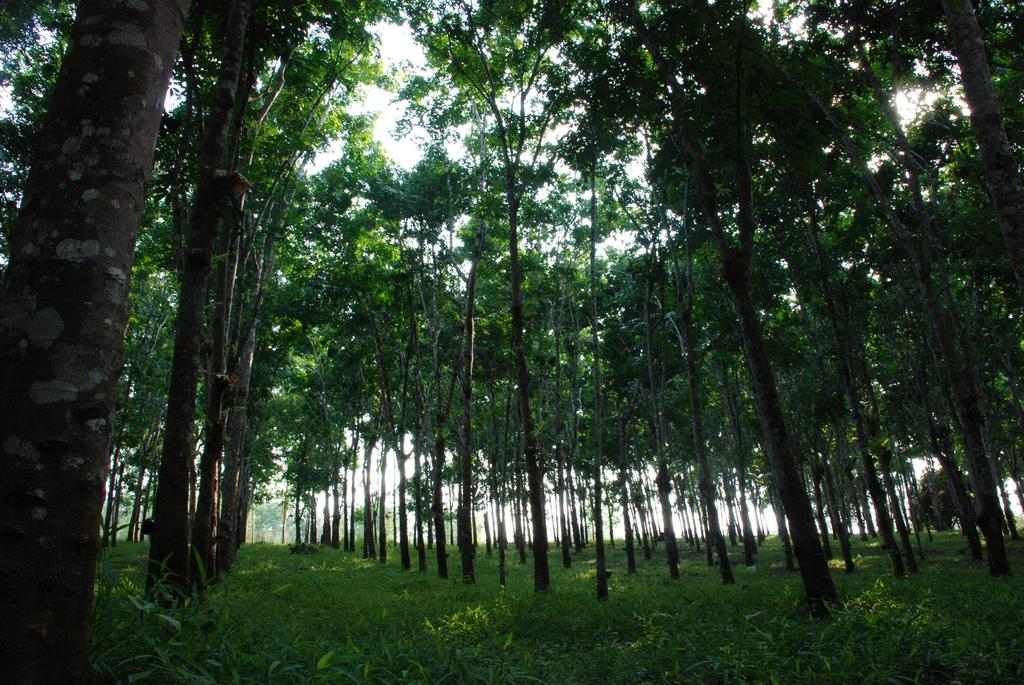What type of vegetation is predominant in the image? There are many tall trees in the image. What is the ground surface like around the trees? The trees are around a grass surface. What type of fuel is being used by the goat in the image? There is no goat present in the image, so it is not possible to determine what type of fuel it might be using. 